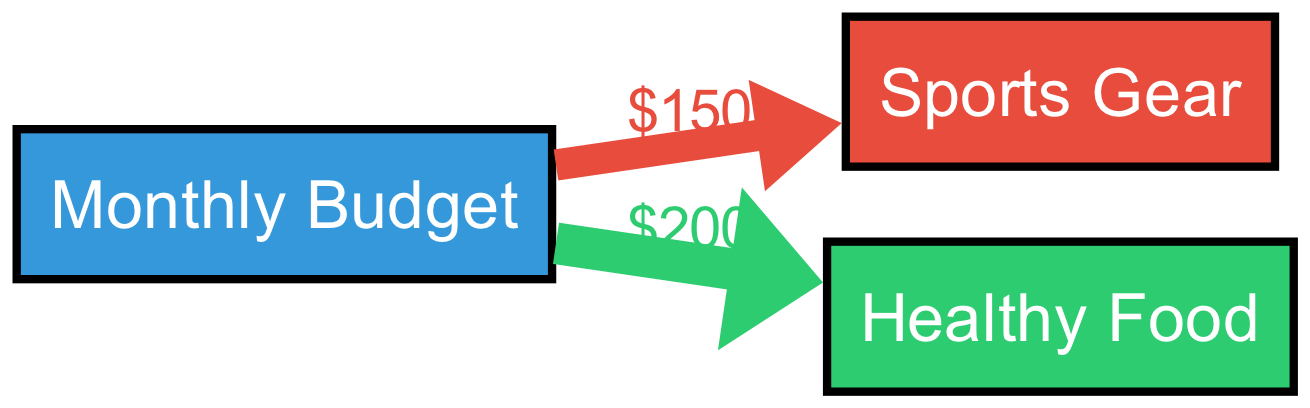What is the total monthly budget allocated? The diagram shows a single source node labeled "Monthly Budget" without specific details on its total, but it can be inferred as the sum of the values flowing to the target nodes. Adding 150 for "Sports Gear" and 200 for "Healthy Food" gives a total of 350.
Answer: 350 How much is spent on Sports Gear? The diagram highlights a direct link from "Monthly Budget" to "Sports Gear" labeled with the value of 150. This directly indicates the amount allocated for this category.
Answer: 150 What is the proportion of the budget spent on Healthy Food? The link labeled for "Healthy Food" shows a value of 200 allocated from the "Monthly Budget." To find the proportion, compare it to the total budget of 350: (200/350) * 100, which equals approximately 57.14%.
Answer: Approximately fifty-seven point fourteen percent How many nodes are present in the diagram? The diagram includes three nodes: "Monthly Budget," "Sports Gear," and "Healthy Food." Counting them gives a total of three nodes.
Answer: 3 What does the color of the Sports Gear node represent? The node for "Sports Gear" is filled with a color defined in the diagram, specifically the color red, which visually distinguishes it from the other categories. This color does not change the meaning but helps identify the node quickly.
Answer: Red What is the total amount spent on both categories? To answer this, add the values attached to the links leading to the categories: 150 for "Sports Gear" and 200 for "Healthy Food." This gives a total of 350 spent across both categories.
Answer: 350 Which category has a higher budget allocation? By directly comparing the values from the links, "Healthy Food" has 200, while "Sports Gear" has only 150. Hence, "Healthy Food" has a higher allocation.
Answer: Healthy Food How does the budget for Healthy Food compare to that for Sports Gear? The diagram shows 200 allocated for "Healthy Food" and 150 for "Sports Gear." Thus, comparing these amounts indicates that "Healthy Food" receives 50 more than "Sports Gear."
Answer: 50 more 